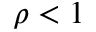Convert formula to latex. <formula><loc_0><loc_0><loc_500><loc_500>\rho < 1</formula> 